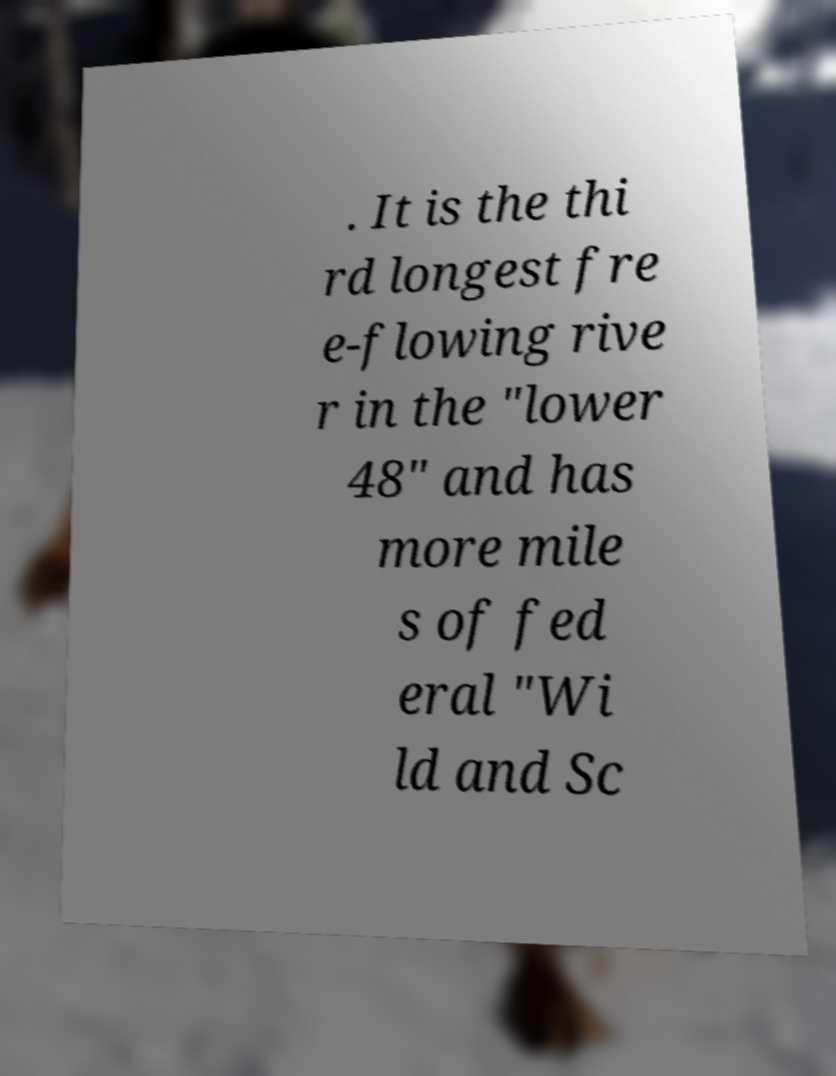Please read and relay the text visible in this image. What does it say? . It is the thi rd longest fre e-flowing rive r in the "lower 48" and has more mile s of fed eral "Wi ld and Sc 